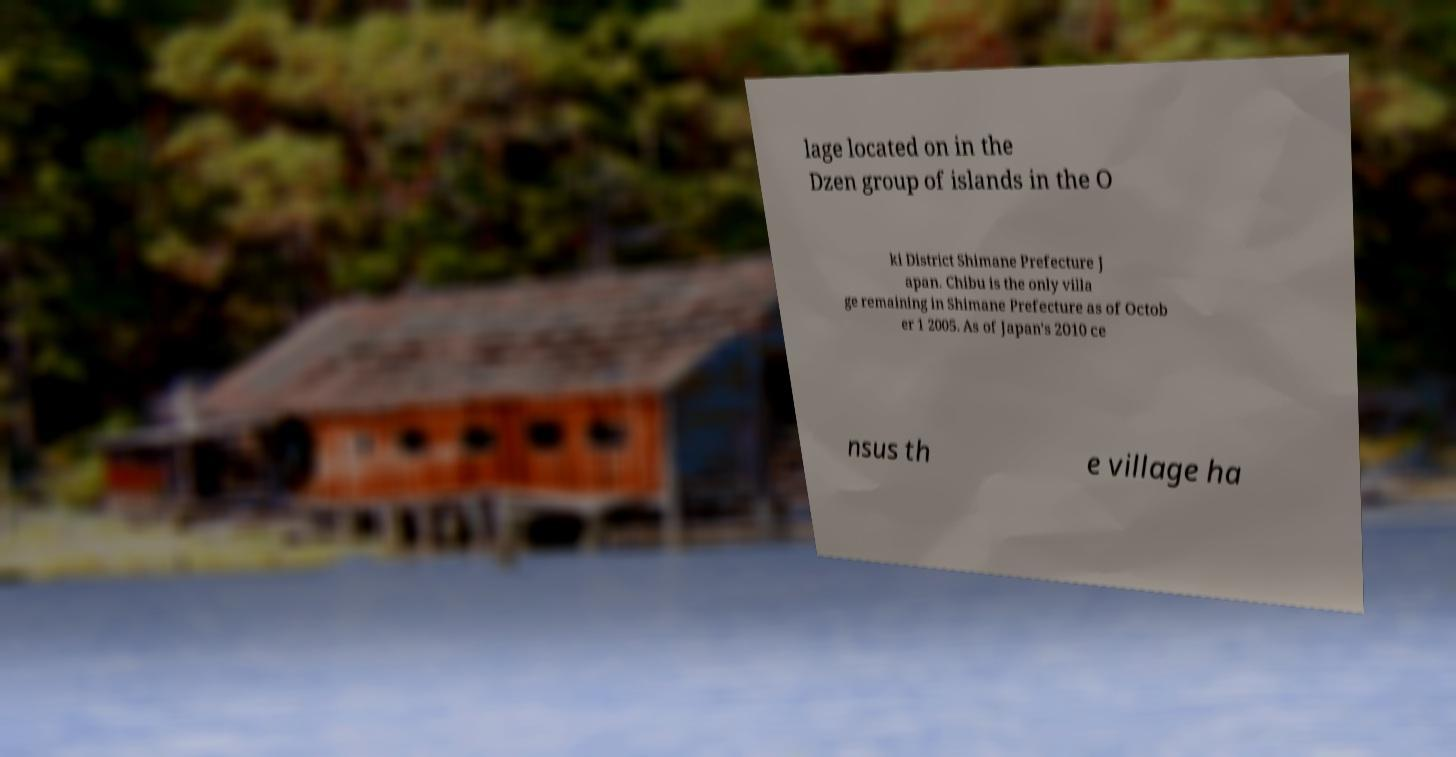Can you accurately transcribe the text from the provided image for me? lage located on in the Dzen group of islands in the O ki District Shimane Prefecture J apan. Chibu is the only villa ge remaining in Shimane Prefecture as of Octob er 1 2005. As of Japan's 2010 ce nsus th e village ha 